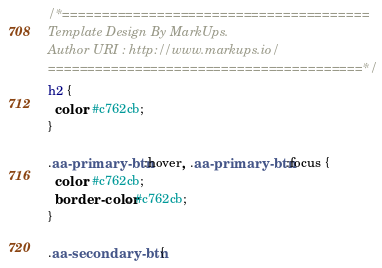Convert code to text. <code><loc_0><loc_0><loc_500><loc_500><_CSS_>
/*=======================================
Template Design By MarkUps.
Author URI : http://www.markups.io/
========================================*/
h2 {
  color: #c762cb;
}

.aa-primary-btn:hover, .aa-primary-btn:focus {
  color: #c762cb;
  border-color: #c762cb;
}

.aa-secondary-btn {</code> 